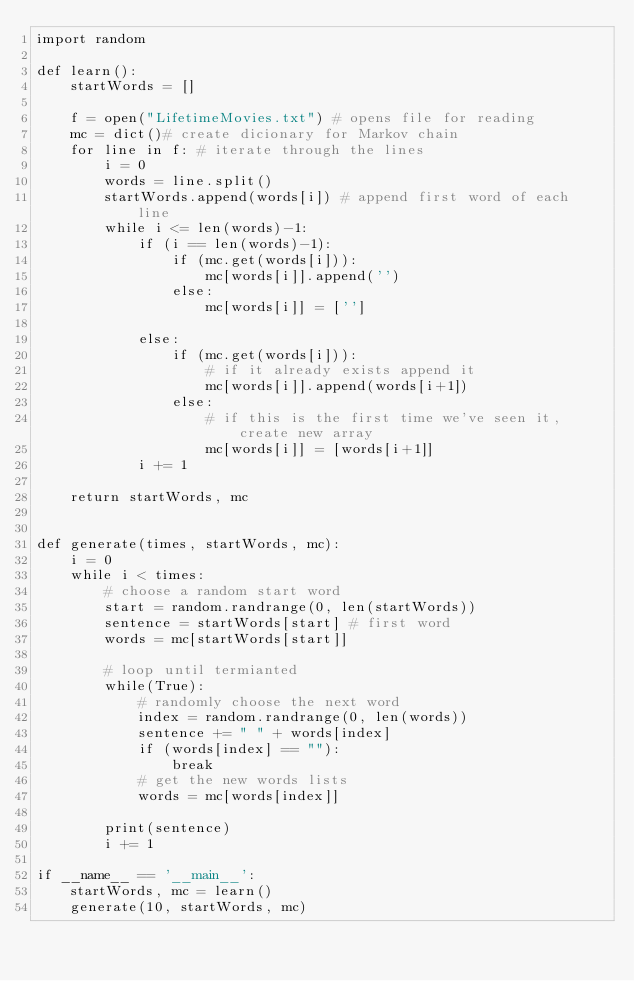Convert code to text. <code><loc_0><loc_0><loc_500><loc_500><_Python_>import random

def learn():
    startWords = []

    f = open("LifetimeMovies.txt") # opens file for reading
    mc = dict()# create dicionary for Markov chain
    for line in f: # iterate through the lines
        i = 0
        words = line.split()
        startWords.append(words[i]) # append first word of each line
        while i <= len(words)-1:
            if (i == len(words)-1):
                if (mc.get(words[i])):
                    mc[words[i]].append('')
                else:
                    mc[words[i]] = ['']

            else:
                if (mc.get(words[i])):
                    # if it already exists append it
                    mc[words[i]].append(words[i+1])
                else:
                    # if this is the first time we've seen it, create new array
                    mc[words[i]] = [words[i+1]]
            i += 1

    return startWords, mc


def generate(times, startWords, mc):
    i = 0
    while i < times:
        # choose a random start word
        start = random.randrange(0, len(startWords))
        sentence = startWords[start] # first word
        words = mc[startWords[start]]

        # loop until termianted
        while(True):
            # randomly choose the next word
            index = random.randrange(0, len(words))
            sentence += " " + words[index]
            if (words[index] == ""):
                break
            # get the new words lists
            words = mc[words[index]]

        print(sentence)
        i += 1

if __name__ == '__main__':
    startWords, mc = learn()
    generate(10, startWords, mc)
</code> 